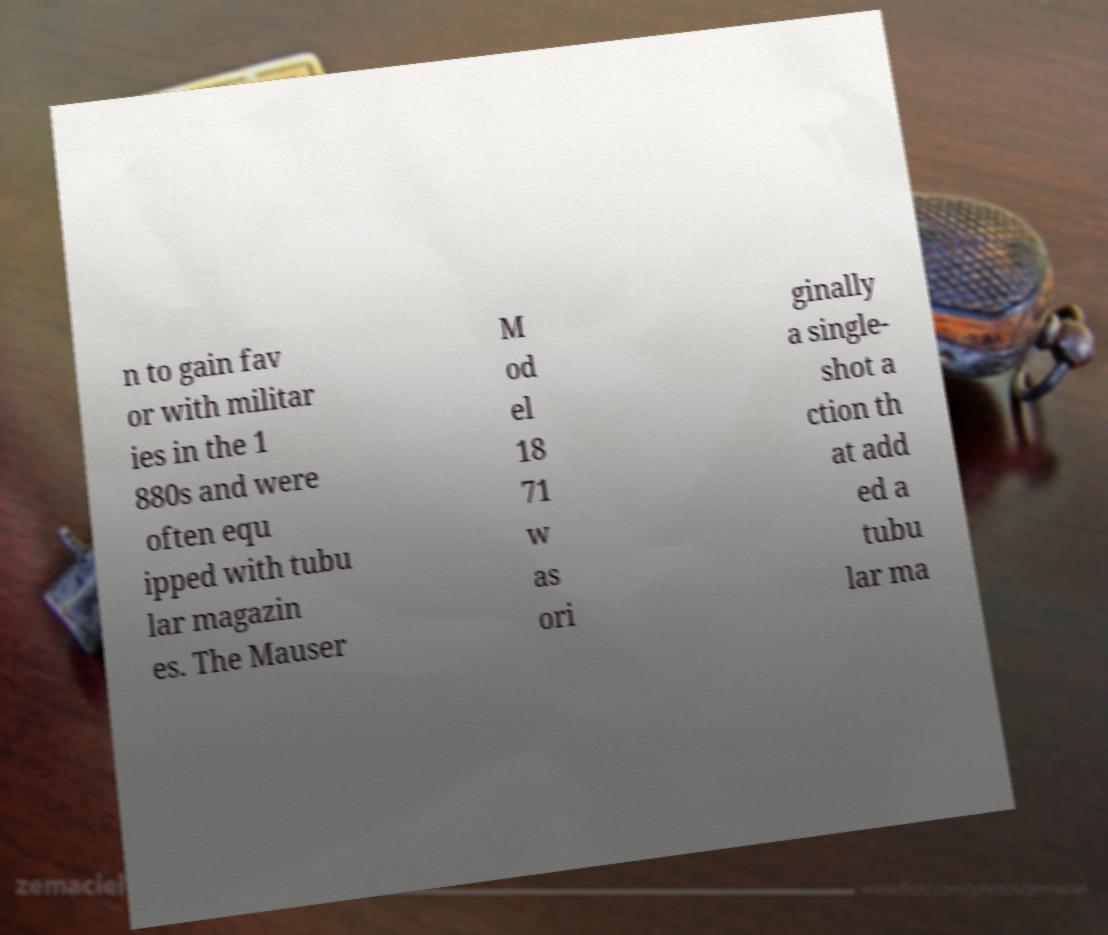Could you assist in decoding the text presented in this image and type it out clearly? n to gain fav or with militar ies in the 1 880s and were often equ ipped with tubu lar magazin es. The Mauser M od el 18 71 w as ori ginally a single- shot a ction th at add ed a tubu lar ma 